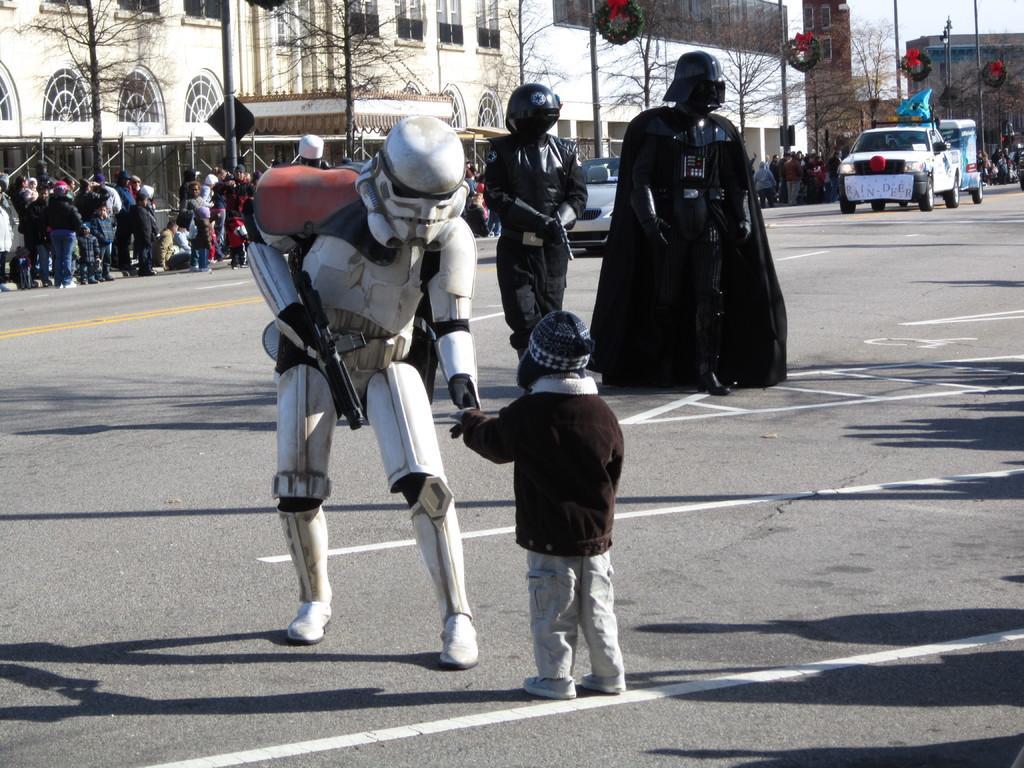Please provide a concise description of this image. Here there are three persons wore fancy dresses and holding a gun in their hands and we can see a kid standing here on the road. In the background there are few people standing and sitting,vehicles,bare trees,poles on the road and we can also see buildings,street lights,poles,windows and sky. 